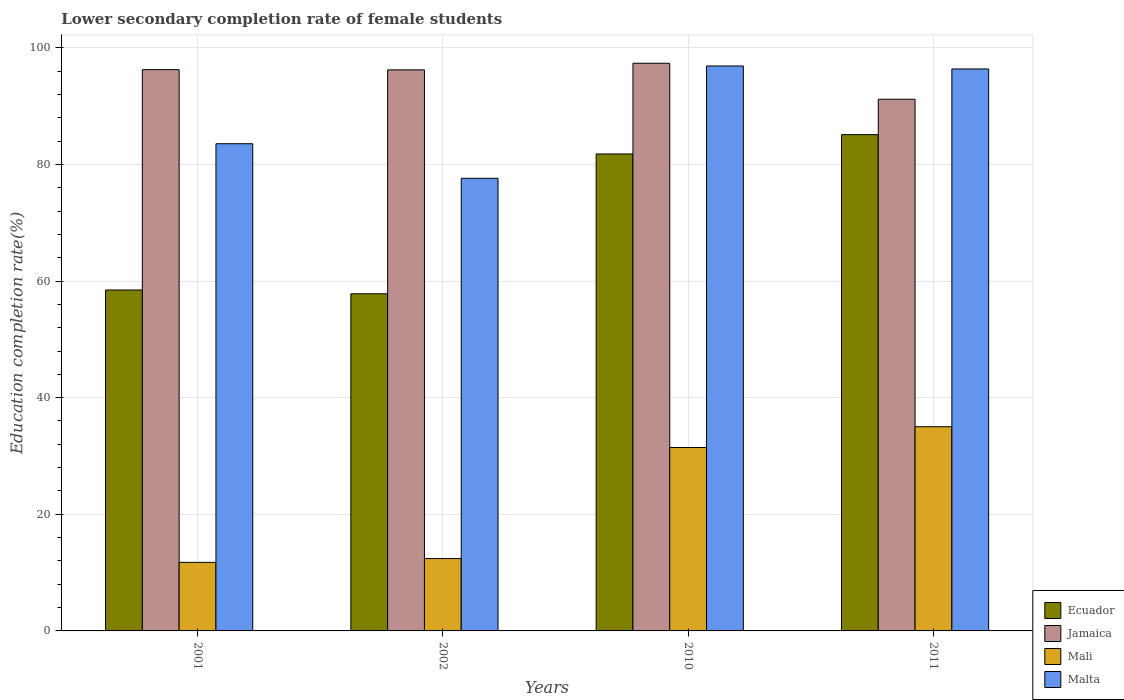How many different coloured bars are there?
Your response must be concise. 4. How many groups of bars are there?
Your answer should be very brief. 4. Are the number of bars per tick equal to the number of legend labels?
Your answer should be very brief. Yes. How many bars are there on the 4th tick from the left?
Your answer should be very brief. 4. In how many cases, is the number of bars for a given year not equal to the number of legend labels?
Your answer should be compact. 0. What is the lower secondary completion rate of female students in Jamaica in 2002?
Make the answer very short. 96.22. Across all years, what is the maximum lower secondary completion rate of female students in Mali?
Your response must be concise. 35.02. Across all years, what is the minimum lower secondary completion rate of female students in Malta?
Offer a very short reply. 77.62. In which year was the lower secondary completion rate of female students in Mali minimum?
Your answer should be compact. 2001. What is the total lower secondary completion rate of female students in Mali in the graph?
Your response must be concise. 90.63. What is the difference between the lower secondary completion rate of female students in Ecuador in 2001 and that in 2010?
Offer a very short reply. -23.33. What is the difference between the lower secondary completion rate of female students in Jamaica in 2011 and the lower secondary completion rate of female students in Malta in 2001?
Your answer should be compact. 7.63. What is the average lower secondary completion rate of female students in Mali per year?
Your answer should be compact. 22.66. In the year 2002, what is the difference between the lower secondary completion rate of female students in Mali and lower secondary completion rate of female students in Malta?
Make the answer very short. -65.21. What is the ratio of the lower secondary completion rate of female students in Jamaica in 2002 to that in 2010?
Your answer should be very brief. 0.99. What is the difference between the highest and the second highest lower secondary completion rate of female students in Malta?
Your answer should be compact. 0.51. What is the difference between the highest and the lowest lower secondary completion rate of female students in Mali?
Provide a short and direct response. 23.26. In how many years, is the lower secondary completion rate of female students in Malta greater than the average lower secondary completion rate of female students in Malta taken over all years?
Your answer should be very brief. 2. Is the sum of the lower secondary completion rate of female students in Malta in 2001 and 2011 greater than the maximum lower secondary completion rate of female students in Mali across all years?
Provide a succinct answer. Yes. Is it the case that in every year, the sum of the lower secondary completion rate of female students in Jamaica and lower secondary completion rate of female students in Malta is greater than the sum of lower secondary completion rate of female students in Mali and lower secondary completion rate of female students in Ecuador?
Your answer should be compact. No. What does the 4th bar from the left in 2002 represents?
Provide a succinct answer. Malta. What does the 2nd bar from the right in 2010 represents?
Provide a succinct answer. Mali. How many bars are there?
Your response must be concise. 16. How many years are there in the graph?
Ensure brevity in your answer.  4. What is the difference between two consecutive major ticks on the Y-axis?
Offer a very short reply. 20. Are the values on the major ticks of Y-axis written in scientific E-notation?
Provide a succinct answer. No. Does the graph contain grids?
Your response must be concise. Yes. How are the legend labels stacked?
Your answer should be very brief. Vertical. What is the title of the graph?
Ensure brevity in your answer.  Lower secondary completion rate of female students. Does "Upper middle income" appear as one of the legend labels in the graph?
Give a very brief answer. No. What is the label or title of the X-axis?
Provide a succinct answer. Years. What is the label or title of the Y-axis?
Provide a short and direct response. Education completion rate(%). What is the Education completion rate(%) in Ecuador in 2001?
Offer a very short reply. 58.46. What is the Education completion rate(%) of Jamaica in 2001?
Provide a short and direct response. 96.25. What is the Education completion rate(%) in Mali in 2001?
Offer a very short reply. 11.76. What is the Education completion rate(%) in Malta in 2001?
Make the answer very short. 83.55. What is the Education completion rate(%) in Ecuador in 2002?
Your answer should be compact. 57.82. What is the Education completion rate(%) in Jamaica in 2002?
Give a very brief answer. 96.22. What is the Education completion rate(%) of Mali in 2002?
Offer a terse response. 12.41. What is the Education completion rate(%) in Malta in 2002?
Provide a succinct answer. 77.62. What is the Education completion rate(%) in Ecuador in 2010?
Provide a short and direct response. 81.8. What is the Education completion rate(%) of Jamaica in 2010?
Offer a very short reply. 97.35. What is the Education completion rate(%) in Mali in 2010?
Your answer should be compact. 31.45. What is the Education completion rate(%) of Malta in 2010?
Your response must be concise. 96.88. What is the Education completion rate(%) in Ecuador in 2011?
Make the answer very short. 85.11. What is the Education completion rate(%) in Jamaica in 2011?
Keep it short and to the point. 91.18. What is the Education completion rate(%) in Mali in 2011?
Offer a terse response. 35.02. What is the Education completion rate(%) in Malta in 2011?
Make the answer very short. 96.37. Across all years, what is the maximum Education completion rate(%) of Ecuador?
Keep it short and to the point. 85.11. Across all years, what is the maximum Education completion rate(%) of Jamaica?
Your answer should be compact. 97.35. Across all years, what is the maximum Education completion rate(%) in Mali?
Keep it short and to the point. 35.02. Across all years, what is the maximum Education completion rate(%) in Malta?
Offer a very short reply. 96.88. Across all years, what is the minimum Education completion rate(%) of Ecuador?
Your response must be concise. 57.82. Across all years, what is the minimum Education completion rate(%) in Jamaica?
Provide a succinct answer. 91.18. Across all years, what is the minimum Education completion rate(%) of Mali?
Your answer should be compact. 11.76. Across all years, what is the minimum Education completion rate(%) of Malta?
Offer a terse response. 77.62. What is the total Education completion rate(%) of Ecuador in the graph?
Your answer should be compact. 283.18. What is the total Education completion rate(%) of Jamaica in the graph?
Give a very brief answer. 381. What is the total Education completion rate(%) in Mali in the graph?
Offer a very short reply. 90.63. What is the total Education completion rate(%) in Malta in the graph?
Your answer should be very brief. 354.43. What is the difference between the Education completion rate(%) of Ecuador in 2001 and that in 2002?
Your answer should be compact. 0.65. What is the difference between the Education completion rate(%) in Jamaica in 2001 and that in 2002?
Offer a very short reply. 0.03. What is the difference between the Education completion rate(%) in Mali in 2001 and that in 2002?
Your answer should be very brief. -0.65. What is the difference between the Education completion rate(%) of Malta in 2001 and that in 2002?
Keep it short and to the point. 5.93. What is the difference between the Education completion rate(%) of Ecuador in 2001 and that in 2010?
Offer a terse response. -23.33. What is the difference between the Education completion rate(%) in Jamaica in 2001 and that in 2010?
Your answer should be very brief. -1.1. What is the difference between the Education completion rate(%) in Mali in 2001 and that in 2010?
Give a very brief answer. -19.69. What is the difference between the Education completion rate(%) of Malta in 2001 and that in 2010?
Make the answer very short. -13.33. What is the difference between the Education completion rate(%) in Ecuador in 2001 and that in 2011?
Offer a very short reply. -26.65. What is the difference between the Education completion rate(%) in Jamaica in 2001 and that in 2011?
Provide a short and direct response. 5.07. What is the difference between the Education completion rate(%) in Mali in 2001 and that in 2011?
Your answer should be compact. -23.26. What is the difference between the Education completion rate(%) of Malta in 2001 and that in 2011?
Your response must be concise. -12.82. What is the difference between the Education completion rate(%) in Ecuador in 2002 and that in 2010?
Your answer should be compact. -23.98. What is the difference between the Education completion rate(%) in Jamaica in 2002 and that in 2010?
Offer a very short reply. -1.13. What is the difference between the Education completion rate(%) of Mali in 2002 and that in 2010?
Keep it short and to the point. -19.04. What is the difference between the Education completion rate(%) in Malta in 2002 and that in 2010?
Keep it short and to the point. -19.26. What is the difference between the Education completion rate(%) in Ecuador in 2002 and that in 2011?
Make the answer very short. -27.29. What is the difference between the Education completion rate(%) of Jamaica in 2002 and that in 2011?
Keep it short and to the point. 5.04. What is the difference between the Education completion rate(%) of Mali in 2002 and that in 2011?
Your answer should be very brief. -22.61. What is the difference between the Education completion rate(%) of Malta in 2002 and that in 2011?
Offer a terse response. -18.75. What is the difference between the Education completion rate(%) in Ecuador in 2010 and that in 2011?
Ensure brevity in your answer.  -3.31. What is the difference between the Education completion rate(%) in Jamaica in 2010 and that in 2011?
Your response must be concise. 6.17. What is the difference between the Education completion rate(%) of Mali in 2010 and that in 2011?
Your response must be concise. -3.57. What is the difference between the Education completion rate(%) of Malta in 2010 and that in 2011?
Your answer should be very brief. 0.51. What is the difference between the Education completion rate(%) of Ecuador in 2001 and the Education completion rate(%) of Jamaica in 2002?
Ensure brevity in your answer.  -37.76. What is the difference between the Education completion rate(%) in Ecuador in 2001 and the Education completion rate(%) in Mali in 2002?
Provide a short and direct response. 46.06. What is the difference between the Education completion rate(%) of Ecuador in 2001 and the Education completion rate(%) of Malta in 2002?
Offer a terse response. -19.16. What is the difference between the Education completion rate(%) of Jamaica in 2001 and the Education completion rate(%) of Mali in 2002?
Keep it short and to the point. 83.84. What is the difference between the Education completion rate(%) in Jamaica in 2001 and the Education completion rate(%) in Malta in 2002?
Your answer should be very brief. 18.63. What is the difference between the Education completion rate(%) of Mali in 2001 and the Education completion rate(%) of Malta in 2002?
Your answer should be very brief. -65.87. What is the difference between the Education completion rate(%) in Ecuador in 2001 and the Education completion rate(%) in Jamaica in 2010?
Offer a very short reply. -38.89. What is the difference between the Education completion rate(%) in Ecuador in 2001 and the Education completion rate(%) in Mali in 2010?
Provide a short and direct response. 27.01. What is the difference between the Education completion rate(%) in Ecuador in 2001 and the Education completion rate(%) in Malta in 2010?
Provide a short and direct response. -38.42. What is the difference between the Education completion rate(%) in Jamaica in 2001 and the Education completion rate(%) in Mali in 2010?
Keep it short and to the point. 64.8. What is the difference between the Education completion rate(%) of Jamaica in 2001 and the Education completion rate(%) of Malta in 2010?
Offer a terse response. -0.63. What is the difference between the Education completion rate(%) of Mali in 2001 and the Education completion rate(%) of Malta in 2010?
Your answer should be very brief. -85.13. What is the difference between the Education completion rate(%) in Ecuador in 2001 and the Education completion rate(%) in Jamaica in 2011?
Provide a succinct answer. -32.71. What is the difference between the Education completion rate(%) in Ecuador in 2001 and the Education completion rate(%) in Mali in 2011?
Give a very brief answer. 23.44. What is the difference between the Education completion rate(%) in Ecuador in 2001 and the Education completion rate(%) in Malta in 2011?
Offer a terse response. -37.91. What is the difference between the Education completion rate(%) in Jamaica in 2001 and the Education completion rate(%) in Mali in 2011?
Ensure brevity in your answer.  61.23. What is the difference between the Education completion rate(%) of Jamaica in 2001 and the Education completion rate(%) of Malta in 2011?
Your response must be concise. -0.12. What is the difference between the Education completion rate(%) in Mali in 2001 and the Education completion rate(%) in Malta in 2011?
Provide a succinct answer. -84.62. What is the difference between the Education completion rate(%) of Ecuador in 2002 and the Education completion rate(%) of Jamaica in 2010?
Provide a short and direct response. -39.53. What is the difference between the Education completion rate(%) of Ecuador in 2002 and the Education completion rate(%) of Mali in 2010?
Offer a terse response. 26.37. What is the difference between the Education completion rate(%) in Ecuador in 2002 and the Education completion rate(%) in Malta in 2010?
Your answer should be very brief. -39.07. What is the difference between the Education completion rate(%) of Jamaica in 2002 and the Education completion rate(%) of Mali in 2010?
Give a very brief answer. 64.77. What is the difference between the Education completion rate(%) of Jamaica in 2002 and the Education completion rate(%) of Malta in 2010?
Your answer should be compact. -0.67. What is the difference between the Education completion rate(%) in Mali in 2002 and the Education completion rate(%) in Malta in 2010?
Your response must be concise. -84.48. What is the difference between the Education completion rate(%) of Ecuador in 2002 and the Education completion rate(%) of Jamaica in 2011?
Provide a short and direct response. -33.36. What is the difference between the Education completion rate(%) of Ecuador in 2002 and the Education completion rate(%) of Mali in 2011?
Offer a terse response. 22.8. What is the difference between the Education completion rate(%) of Ecuador in 2002 and the Education completion rate(%) of Malta in 2011?
Provide a succinct answer. -38.56. What is the difference between the Education completion rate(%) of Jamaica in 2002 and the Education completion rate(%) of Mali in 2011?
Make the answer very short. 61.2. What is the difference between the Education completion rate(%) in Jamaica in 2002 and the Education completion rate(%) in Malta in 2011?
Your answer should be compact. -0.16. What is the difference between the Education completion rate(%) of Mali in 2002 and the Education completion rate(%) of Malta in 2011?
Provide a succinct answer. -83.97. What is the difference between the Education completion rate(%) in Ecuador in 2010 and the Education completion rate(%) in Jamaica in 2011?
Offer a very short reply. -9.38. What is the difference between the Education completion rate(%) of Ecuador in 2010 and the Education completion rate(%) of Mali in 2011?
Make the answer very short. 46.78. What is the difference between the Education completion rate(%) of Ecuador in 2010 and the Education completion rate(%) of Malta in 2011?
Ensure brevity in your answer.  -14.58. What is the difference between the Education completion rate(%) of Jamaica in 2010 and the Education completion rate(%) of Mali in 2011?
Your answer should be very brief. 62.33. What is the difference between the Education completion rate(%) in Jamaica in 2010 and the Education completion rate(%) in Malta in 2011?
Keep it short and to the point. 0.98. What is the difference between the Education completion rate(%) in Mali in 2010 and the Education completion rate(%) in Malta in 2011?
Make the answer very short. -64.92. What is the average Education completion rate(%) of Ecuador per year?
Offer a very short reply. 70.8. What is the average Education completion rate(%) in Jamaica per year?
Your answer should be compact. 95.25. What is the average Education completion rate(%) in Mali per year?
Offer a terse response. 22.66. What is the average Education completion rate(%) of Malta per year?
Your answer should be compact. 88.61. In the year 2001, what is the difference between the Education completion rate(%) in Ecuador and Education completion rate(%) in Jamaica?
Make the answer very short. -37.79. In the year 2001, what is the difference between the Education completion rate(%) of Ecuador and Education completion rate(%) of Mali?
Offer a terse response. 46.71. In the year 2001, what is the difference between the Education completion rate(%) of Ecuador and Education completion rate(%) of Malta?
Offer a very short reply. -25.09. In the year 2001, what is the difference between the Education completion rate(%) of Jamaica and Education completion rate(%) of Mali?
Keep it short and to the point. 84.5. In the year 2001, what is the difference between the Education completion rate(%) in Jamaica and Education completion rate(%) in Malta?
Provide a succinct answer. 12.7. In the year 2001, what is the difference between the Education completion rate(%) in Mali and Education completion rate(%) in Malta?
Provide a short and direct response. -71.79. In the year 2002, what is the difference between the Education completion rate(%) in Ecuador and Education completion rate(%) in Jamaica?
Keep it short and to the point. -38.4. In the year 2002, what is the difference between the Education completion rate(%) in Ecuador and Education completion rate(%) in Mali?
Your answer should be very brief. 45.41. In the year 2002, what is the difference between the Education completion rate(%) in Ecuador and Education completion rate(%) in Malta?
Make the answer very short. -19.81. In the year 2002, what is the difference between the Education completion rate(%) in Jamaica and Education completion rate(%) in Mali?
Your answer should be compact. 83.81. In the year 2002, what is the difference between the Education completion rate(%) in Jamaica and Education completion rate(%) in Malta?
Your response must be concise. 18.6. In the year 2002, what is the difference between the Education completion rate(%) in Mali and Education completion rate(%) in Malta?
Your response must be concise. -65.21. In the year 2010, what is the difference between the Education completion rate(%) of Ecuador and Education completion rate(%) of Jamaica?
Ensure brevity in your answer.  -15.55. In the year 2010, what is the difference between the Education completion rate(%) in Ecuador and Education completion rate(%) in Mali?
Offer a terse response. 50.35. In the year 2010, what is the difference between the Education completion rate(%) of Ecuador and Education completion rate(%) of Malta?
Make the answer very short. -15.09. In the year 2010, what is the difference between the Education completion rate(%) of Jamaica and Education completion rate(%) of Mali?
Give a very brief answer. 65.9. In the year 2010, what is the difference between the Education completion rate(%) of Jamaica and Education completion rate(%) of Malta?
Ensure brevity in your answer.  0.47. In the year 2010, what is the difference between the Education completion rate(%) of Mali and Education completion rate(%) of Malta?
Keep it short and to the point. -65.43. In the year 2011, what is the difference between the Education completion rate(%) in Ecuador and Education completion rate(%) in Jamaica?
Your answer should be compact. -6.07. In the year 2011, what is the difference between the Education completion rate(%) of Ecuador and Education completion rate(%) of Mali?
Provide a short and direct response. 50.09. In the year 2011, what is the difference between the Education completion rate(%) of Ecuador and Education completion rate(%) of Malta?
Provide a short and direct response. -11.26. In the year 2011, what is the difference between the Education completion rate(%) in Jamaica and Education completion rate(%) in Mali?
Give a very brief answer. 56.16. In the year 2011, what is the difference between the Education completion rate(%) in Jamaica and Education completion rate(%) in Malta?
Make the answer very short. -5.2. In the year 2011, what is the difference between the Education completion rate(%) in Mali and Education completion rate(%) in Malta?
Give a very brief answer. -61.35. What is the ratio of the Education completion rate(%) in Ecuador in 2001 to that in 2002?
Give a very brief answer. 1.01. What is the ratio of the Education completion rate(%) in Mali in 2001 to that in 2002?
Ensure brevity in your answer.  0.95. What is the ratio of the Education completion rate(%) of Malta in 2001 to that in 2002?
Provide a short and direct response. 1.08. What is the ratio of the Education completion rate(%) in Ecuador in 2001 to that in 2010?
Your answer should be very brief. 0.71. What is the ratio of the Education completion rate(%) in Jamaica in 2001 to that in 2010?
Ensure brevity in your answer.  0.99. What is the ratio of the Education completion rate(%) of Mali in 2001 to that in 2010?
Make the answer very short. 0.37. What is the ratio of the Education completion rate(%) in Malta in 2001 to that in 2010?
Ensure brevity in your answer.  0.86. What is the ratio of the Education completion rate(%) of Ecuador in 2001 to that in 2011?
Offer a very short reply. 0.69. What is the ratio of the Education completion rate(%) in Jamaica in 2001 to that in 2011?
Ensure brevity in your answer.  1.06. What is the ratio of the Education completion rate(%) of Mali in 2001 to that in 2011?
Offer a terse response. 0.34. What is the ratio of the Education completion rate(%) of Malta in 2001 to that in 2011?
Make the answer very short. 0.87. What is the ratio of the Education completion rate(%) in Ecuador in 2002 to that in 2010?
Provide a short and direct response. 0.71. What is the ratio of the Education completion rate(%) of Jamaica in 2002 to that in 2010?
Offer a terse response. 0.99. What is the ratio of the Education completion rate(%) of Mali in 2002 to that in 2010?
Offer a very short reply. 0.39. What is the ratio of the Education completion rate(%) in Malta in 2002 to that in 2010?
Give a very brief answer. 0.8. What is the ratio of the Education completion rate(%) of Ecuador in 2002 to that in 2011?
Your answer should be very brief. 0.68. What is the ratio of the Education completion rate(%) in Jamaica in 2002 to that in 2011?
Provide a succinct answer. 1.06. What is the ratio of the Education completion rate(%) in Mali in 2002 to that in 2011?
Your answer should be compact. 0.35. What is the ratio of the Education completion rate(%) in Malta in 2002 to that in 2011?
Make the answer very short. 0.81. What is the ratio of the Education completion rate(%) in Ecuador in 2010 to that in 2011?
Your answer should be very brief. 0.96. What is the ratio of the Education completion rate(%) of Jamaica in 2010 to that in 2011?
Make the answer very short. 1.07. What is the ratio of the Education completion rate(%) of Mali in 2010 to that in 2011?
Provide a succinct answer. 0.9. What is the difference between the highest and the second highest Education completion rate(%) in Ecuador?
Your answer should be very brief. 3.31. What is the difference between the highest and the second highest Education completion rate(%) of Jamaica?
Provide a short and direct response. 1.1. What is the difference between the highest and the second highest Education completion rate(%) in Mali?
Your response must be concise. 3.57. What is the difference between the highest and the second highest Education completion rate(%) in Malta?
Offer a very short reply. 0.51. What is the difference between the highest and the lowest Education completion rate(%) of Ecuador?
Make the answer very short. 27.29. What is the difference between the highest and the lowest Education completion rate(%) in Jamaica?
Your answer should be compact. 6.17. What is the difference between the highest and the lowest Education completion rate(%) of Mali?
Offer a very short reply. 23.26. What is the difference between the highest and the lowest Education completion rate(%) in Malta?
Your answer should be compact. 19.26. 